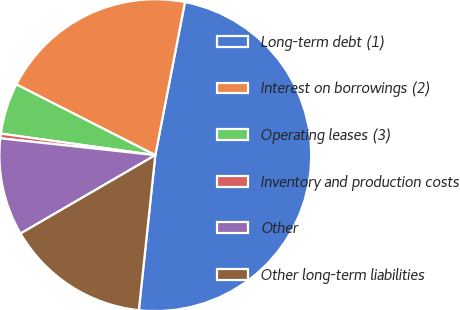Convert chart. <chart><loc_0><loc_0><loc_500><loc_500><pie_chart><fcel>Long-term debt (1)<fcel>Interest on borrowings (2)<fcel>Operating leases (3)<fcel>Inventory and production costs<fcel>Other<fcel>Other long-term liabilities<nl><fcel>48.64%<fcel>20.55%<fcel>5.29%<fcel>0.48%<fcel>10.11%<fcel>14.93%<nl></chart> 